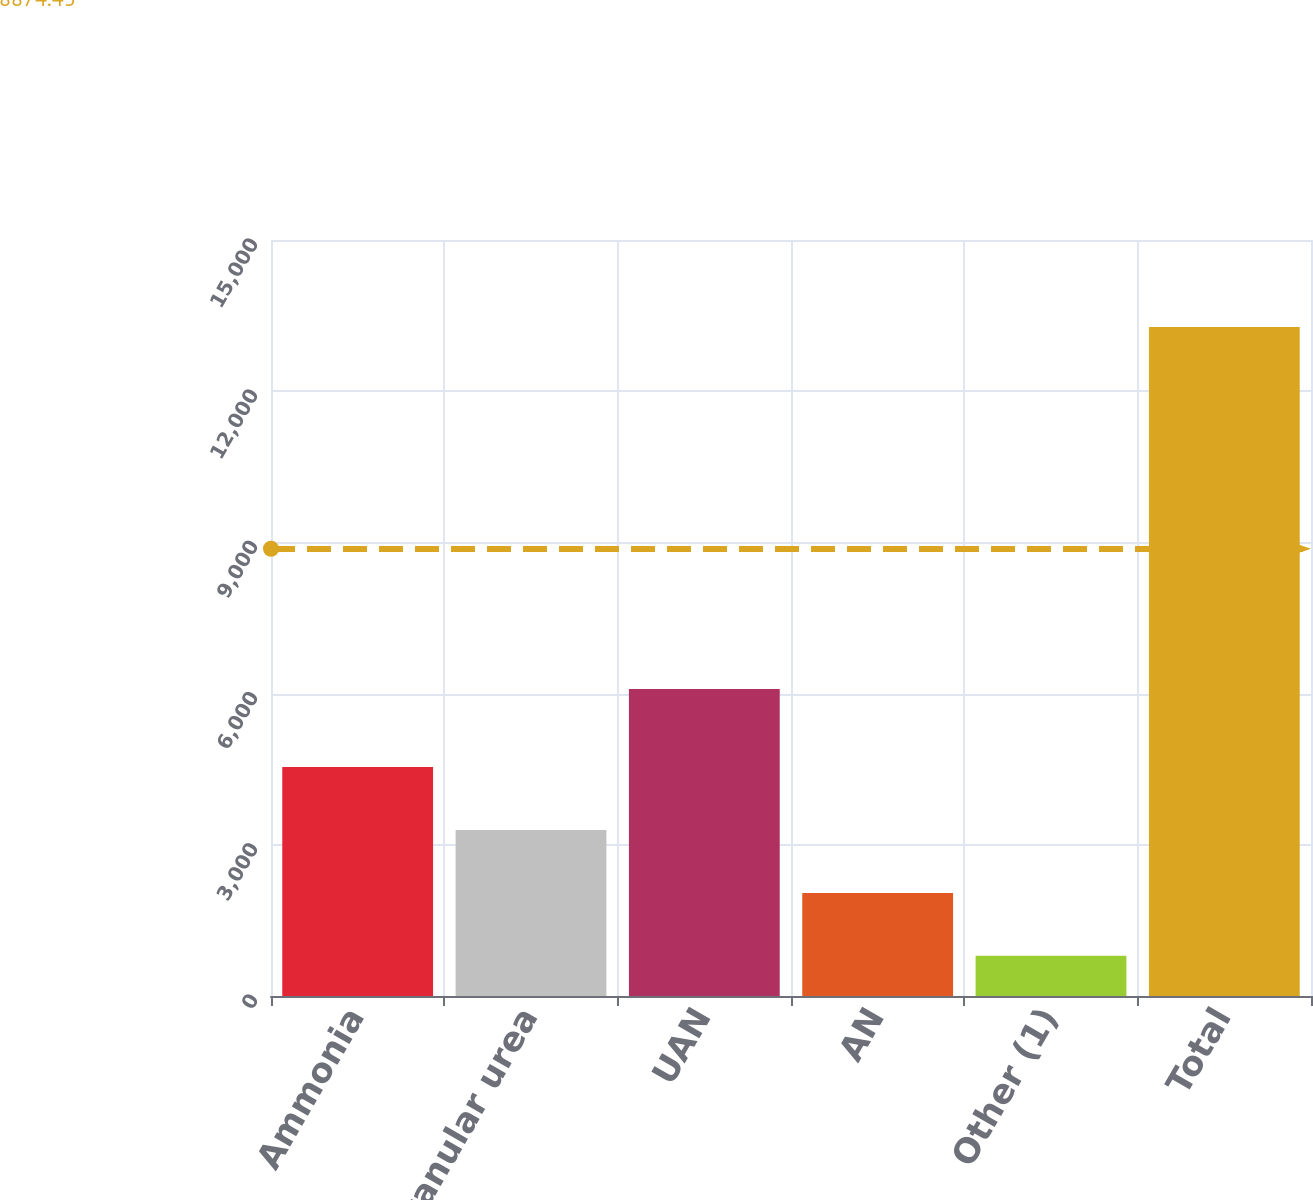Convert chart to OTSL. <chart><loc_0><loc_0><loc_500><loc_500><bar_chart><fcel>Ammonia<fcel>Granular urea<fcel>UAN<fcel>AN<fcel>Other (1)<fcel>Total<nl><fcel>4541.4<fcel>3293.6<fcel>6092<fcel>2045.8<fcel>798<fcel>13276<nl></chart> 